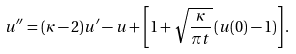Convert formula to latex. <formula><loc_0><loc_0><loc_500><loc_500>u ^ { \prime \prime } = ( \kappa - 2 ) u ^ { \prime } - u + \left [ 1 + \sqrt { \frac { \kappa } { \pi t } } \left ( u ( 0 ) - 1 \right ) \right ] .</formula> 